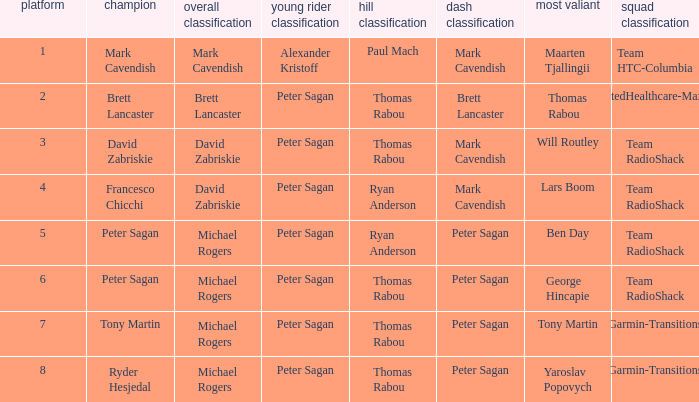When Brett Lancaster won the general classification, who won the team calssification? UnitedHealthcare-Maxxis. 